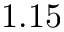<formula> <loc_0><loc_0><loc_500><loc_500>1 . 1 5</formula> 